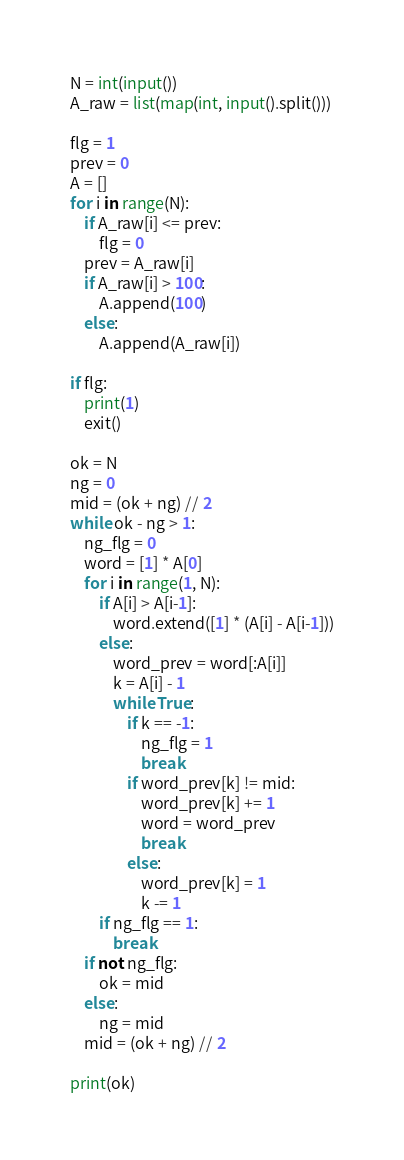Convert code to text. <code><loc_0><loc_0><loc_500><loc_500><_Python_>N = int(input())
A_raw = list(map(int, input().split()))

flg = 1
prev = 0
A = []
for i in range(N):
    if A_raw[i] <= prev:
        flg = 0
    prev = A_raw[i]
    if A_raw[i] > 100:
        A.append(100)
    else:
        A.append(A_raw[i])

if flg:
    print(1)
    exit()

ok = N
ng = 0
mid = (ok + ng) // 2
while ok - ng > 1:
    ng_flg = 0
    word = [1] * A[0]
    for i in range(1, N):
        if A[i] > A[i-1]:
            word.extend([1] * (A[i] - A[i-1]))
        else:
            word_prev = word[:A[i]]
            k = A[i] - 1
            while True:
                if k == -1:
                    ng_flg = 1
                    break
                if word_prev[k] != mid:
                    word_prev[k] += 1
                    word = word_prev
                    break
                else:
                    word_prev[k] = 1
                    k -= 1
        if ng_flg == 1:
            break
    if not ng_flg:
        ok = mid
    else:
        ng = mid
    mid = (ok + ng) // 2

print(ok)
</code> 